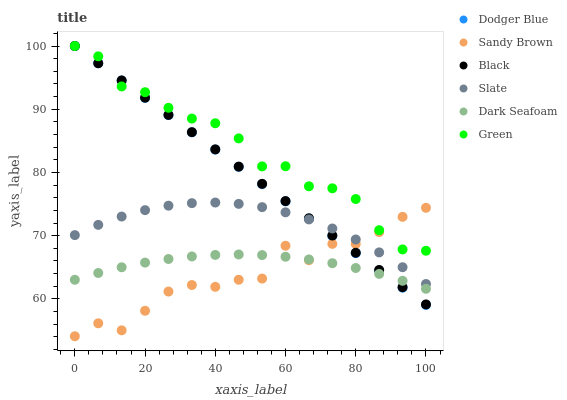Does Sandy Brown have the minimum area under the curve?
Answer yes or no. Yes. Does Green have the maximum area under the curve?
Answer yes or no. Yes. Does Dark Seafoam have the minimum area under the curve?
Answer yes or no. No. Does Dark Seafoam have the maximum area under the curve?
Answer yes or no. No. Is Black the smoothest?
Answer yes or no. Yes. Is Sandy Brown the roughest?
Answer yes or no. Yes. Is Dark Seafoam the smoothest?
Answer yes or no. No. Is Dark Seafoam the roughest?
Answer yes or no. No. Does Sandy Brown have the lowest value?
Answer yes or no. Yes. Does Dark Seafoam have the lowest value?
Answer yes or no. No. Does Dodger Blue have the highest value?
Answer yes or no. Yes. Does Dark Seafoam have the highest value?
Answer yes or no. No. Is Slate less than Green?
Answer yes or no. Yes. Is Green greater than Dark Seafoam?
Answer yes or no. Yes. Does Green intersect Black?
Answer yes or no. Yes. Is Green less than Black?
Answer yes or no. No. Is Green greater than Black?
Answer yes or no. No. Does Slate intersect Green?
Answer yes or no. No. 